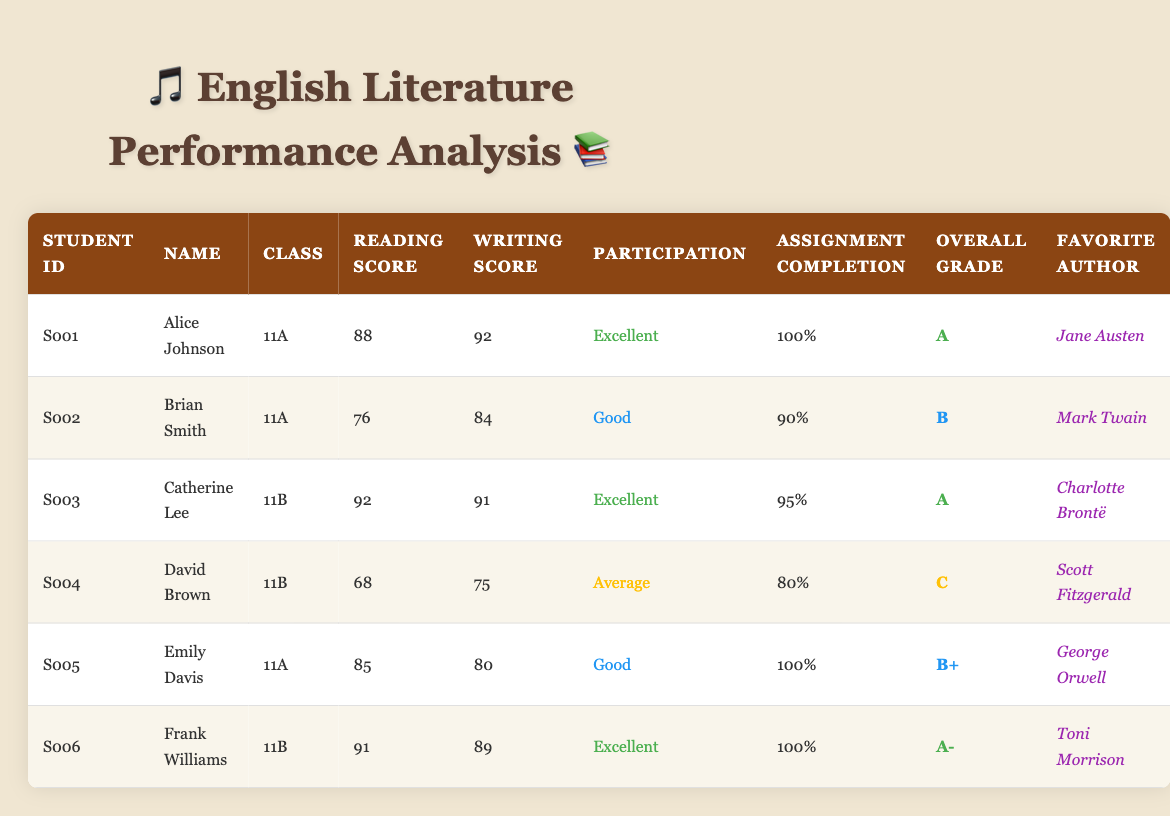What is the highest reading score among the students? Looking through the Reading Score column, the highest value is 92, which belongs to both Catherine Lee and Frank Williams.
Answer: 92 Which student has the lowest overall grade? In the Overall Grade column, the lowest grade is C, which is given to David Brown.
Answer: David Brown What is the average writing score for Class 11A? There are three students in Class 11A: Alice Johnson (92), Brian Smith (84), and Emily Davis (80). The sum of their writing scores is 92 + 84 + 80 = 256. There are 3 students, so the average is 256/3 = 85.33.
Answer: 85.33 Is Frank Williams's favorite author a female author? Frank Williams's favorite author is Toni Morrison, who is indeed a female author.
Answer: Yes How many students have an assignment completion percentage of 100%? Alice Johnson, Frank Williams, and Emily Davis all have an assignment completion percentage of 100%. Counting these students gives us a total of 3.
Answer: 3 What is the participation status of students in Class 11B? In Class 11B, there are two students: Catherine Lee (Excellent) and David Brown (Average). Both statuses indicate different levels of participation between the two students.
Answer: Excellent and Average Calculate the difference between the highest reading score and the lowest writing score. The highest reading score is 92 (Catherine Lee), and the lowest writing score is 75 (David Brown). The difference is 92 - 75 = 17.
Answer: 17 Which student has a favorite author who lived in the 19th century? Jane Austen (Alice Johnson), Charlotte Brontë (Catherine Lee), and Scott Fitzgerald (David Brown) lived in the 19th century. All three students have authors in their favorites that meet this criterion.
Answer: Alice Johnson, Catherine Lee, David Brown What is the overall grade of the student with the best assignment completion? Alice Johnson and Frank Williams both have 100% assignment completion. However, Alice has an overall grade of A, while Frank has A-. The best overall grade is A from Alice Johnson.
Answer: A 